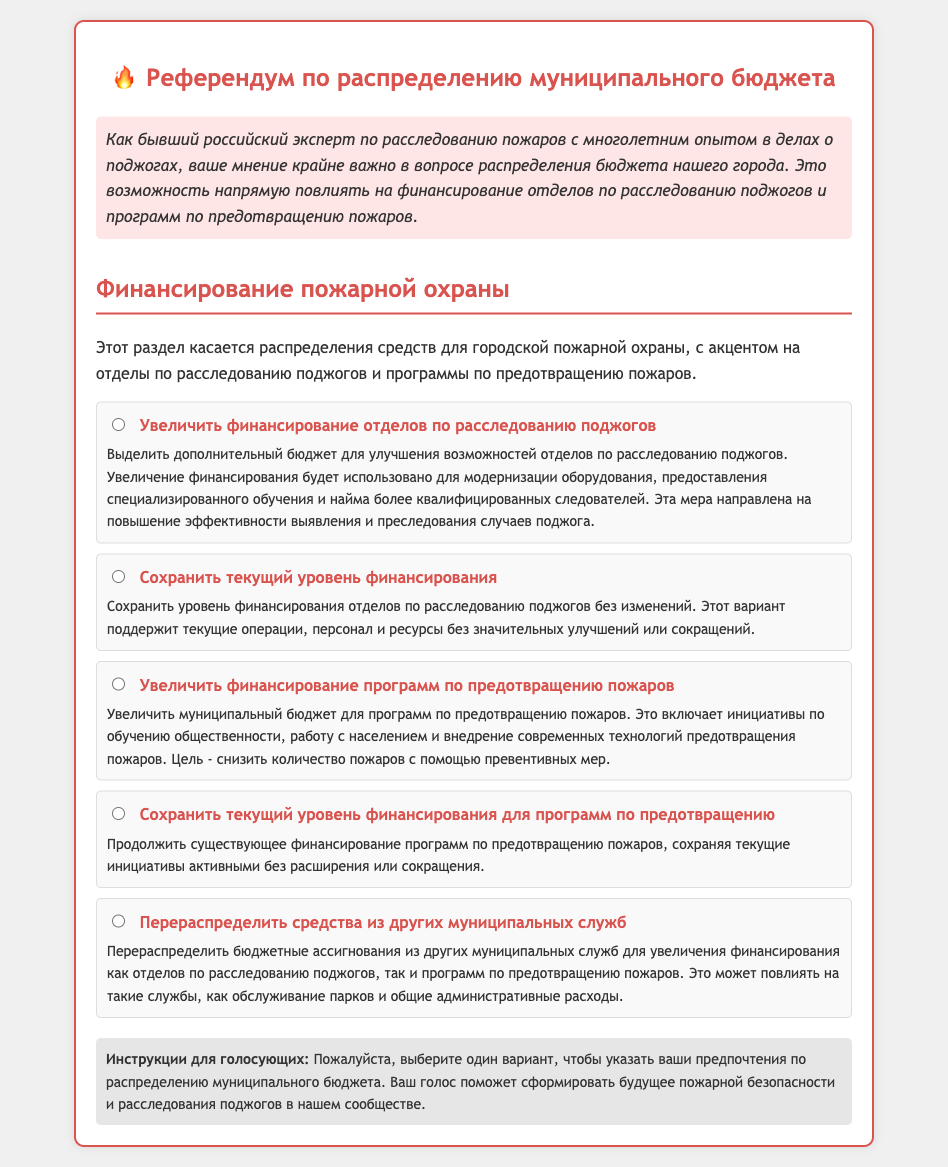What is the main topic of the referendum? The main topic of the referendum is the allocation of municipal budget funds with focus on fire investigation units and fire prevention programs.
Answer: Allocation of municipal budget funds What is the color of the ballot title? The color of the ballot title is red, specifically associated with the color #d9534f.
Answer: Red What is one of the proposed uses of increased funding for fire investigation units? The increased funding will be used to modernize equipment, provide specialized training, and hire more qualified investigators.
Answer: Modernize equipment What does the second option suggest regarding fire investigation funding? The second option suggests maintaining the current level of funding for fire investigation units without changes.
Answer: Current level of funding How many options are provided for fire funding decisions? There are five options provided for fire funding decisions.
Answer: Five What aspect of fire safety does the third option focus on? The third option focuses on increasing funding for fire prevention programs.
Answer: Fire prevention programs What is the objective of the increased funding for fire prevention programs? The objective is to reduce the number of fires through preventive measures.
Answer: Reduce the number of fires What does the instructions section request voters to do? The instructions request voters to select one option to indicate their preferences regarding the municipal budget allocation.
Answer: Select one option Which phrase describes the funding strategy of redistributing funds? The phrase used is "Перераспределить средства из других муниципальных служб".
Answer: Перераспределить средства из других муниципальных служб 